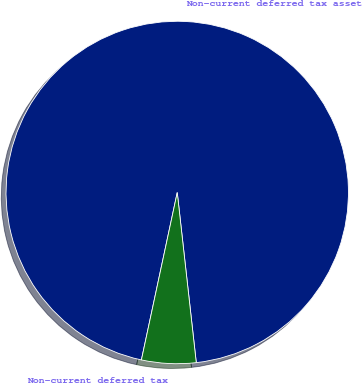<chart> <loc_0><loc_0><loc_500><loc_500><pie_chart><fcel>Non-current deferred tax asset<fcel>Non-current deferred tax<nl><fcel>94.87%<fcel>5.13%<nl></chart> 